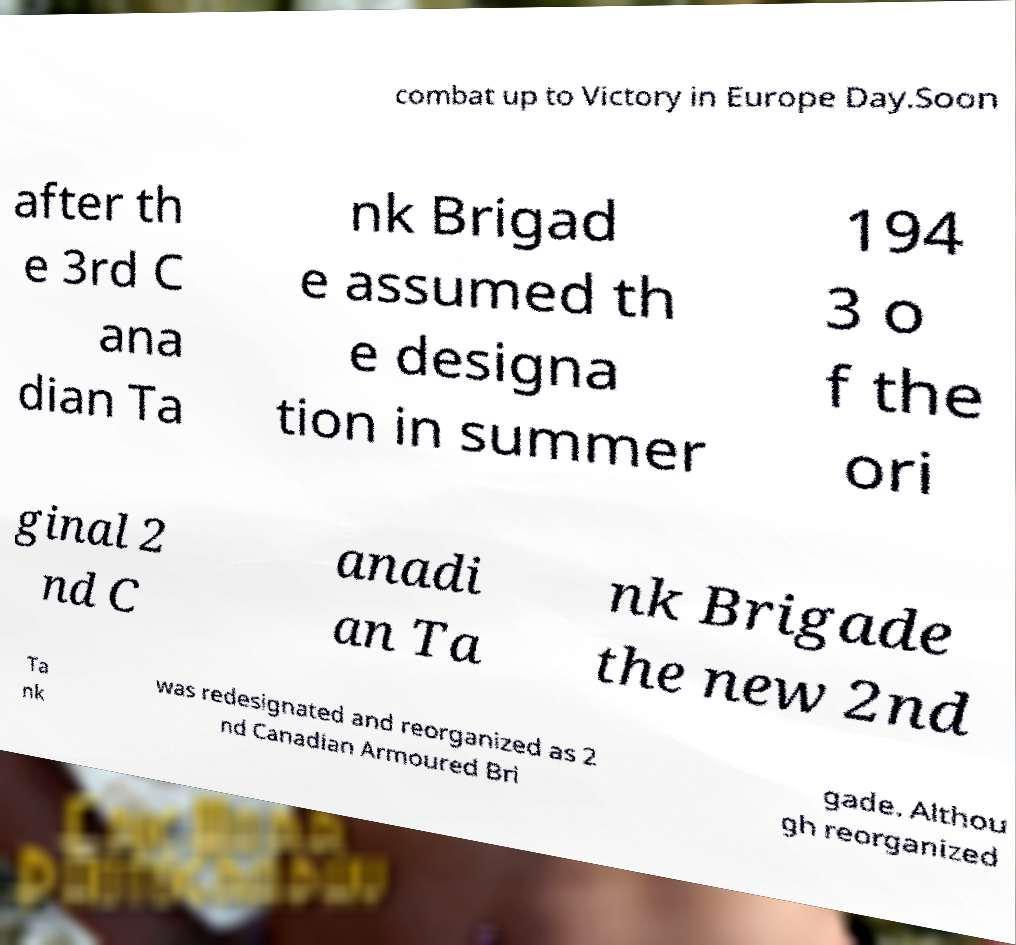What messages or text are displayed in this image? I need them in a readable, typed format. combat up to Victory in Europe Day.Soon after th e 3rd C ana dian Ta nk Brigad e assumed th e designa tion in summer 194 3 o f the ori ginal 2 nd C anadi an Ta nk Brigade the new 2nd Ta nk was redesignated and reorganized as 2 nd Canadian Armoured Bri gade. Althou gh reorganized 